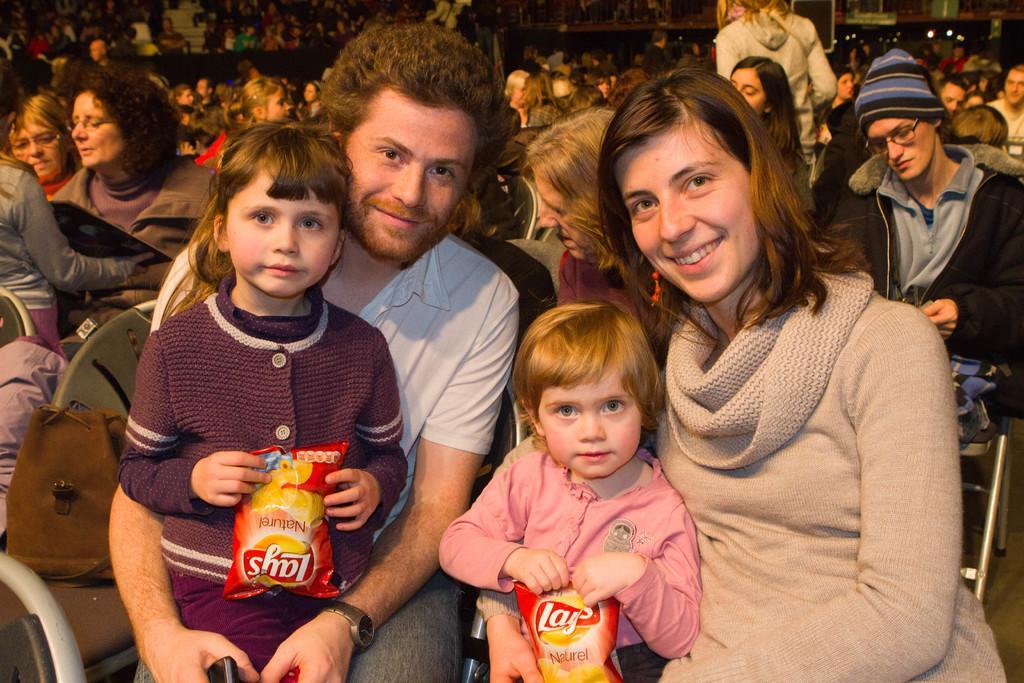Could you give a brief overview of what you see in this image? In this image we can see a man and woman is sitting on the chair and two girls are there. Man is wearing white shirt with jeans and the woman is wearing grey color top. One girl is wearing brown color sweater and holding lays packet in her hand and the other one is wearing pink color top and she is also holding lays packet in her hand. Behind them so many people are sitting and standing. 